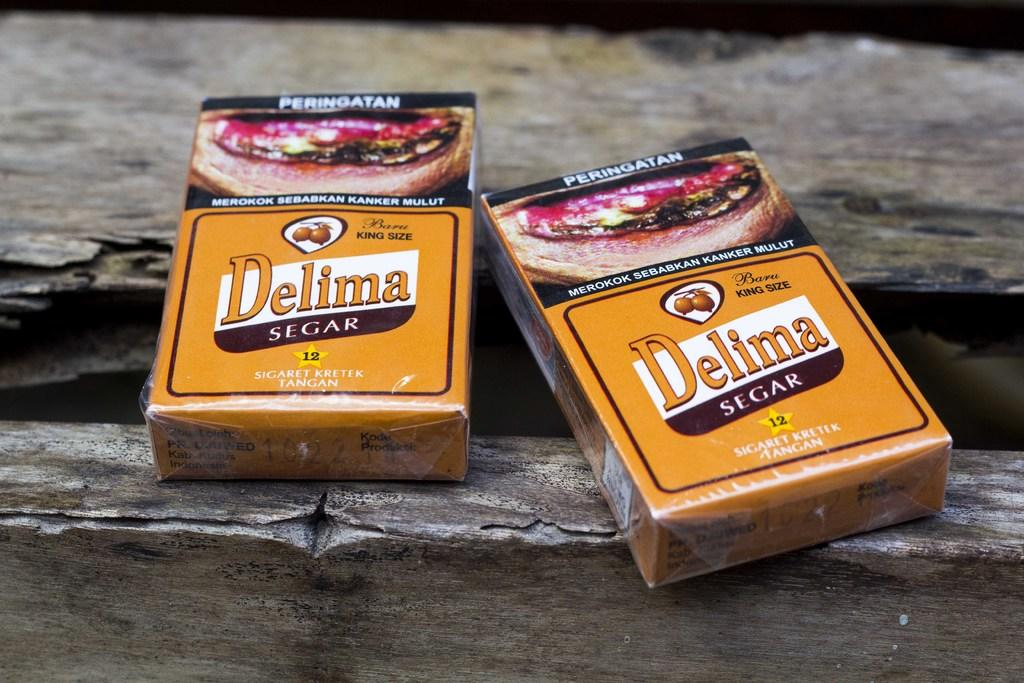What objects are present in the image related to smoking? There are two cigarette packets in the image. What can be found on the cigarette packets? There is text on the cigarette packets. What type of hobbies are depicted on the cigarette packets? There are no hobbies depicted on the cigarette packets; they only contain text. How does the plough relate to the cigarette packets in the image? There is no plough present in the image, so it does not relate to the cigarette packets. 